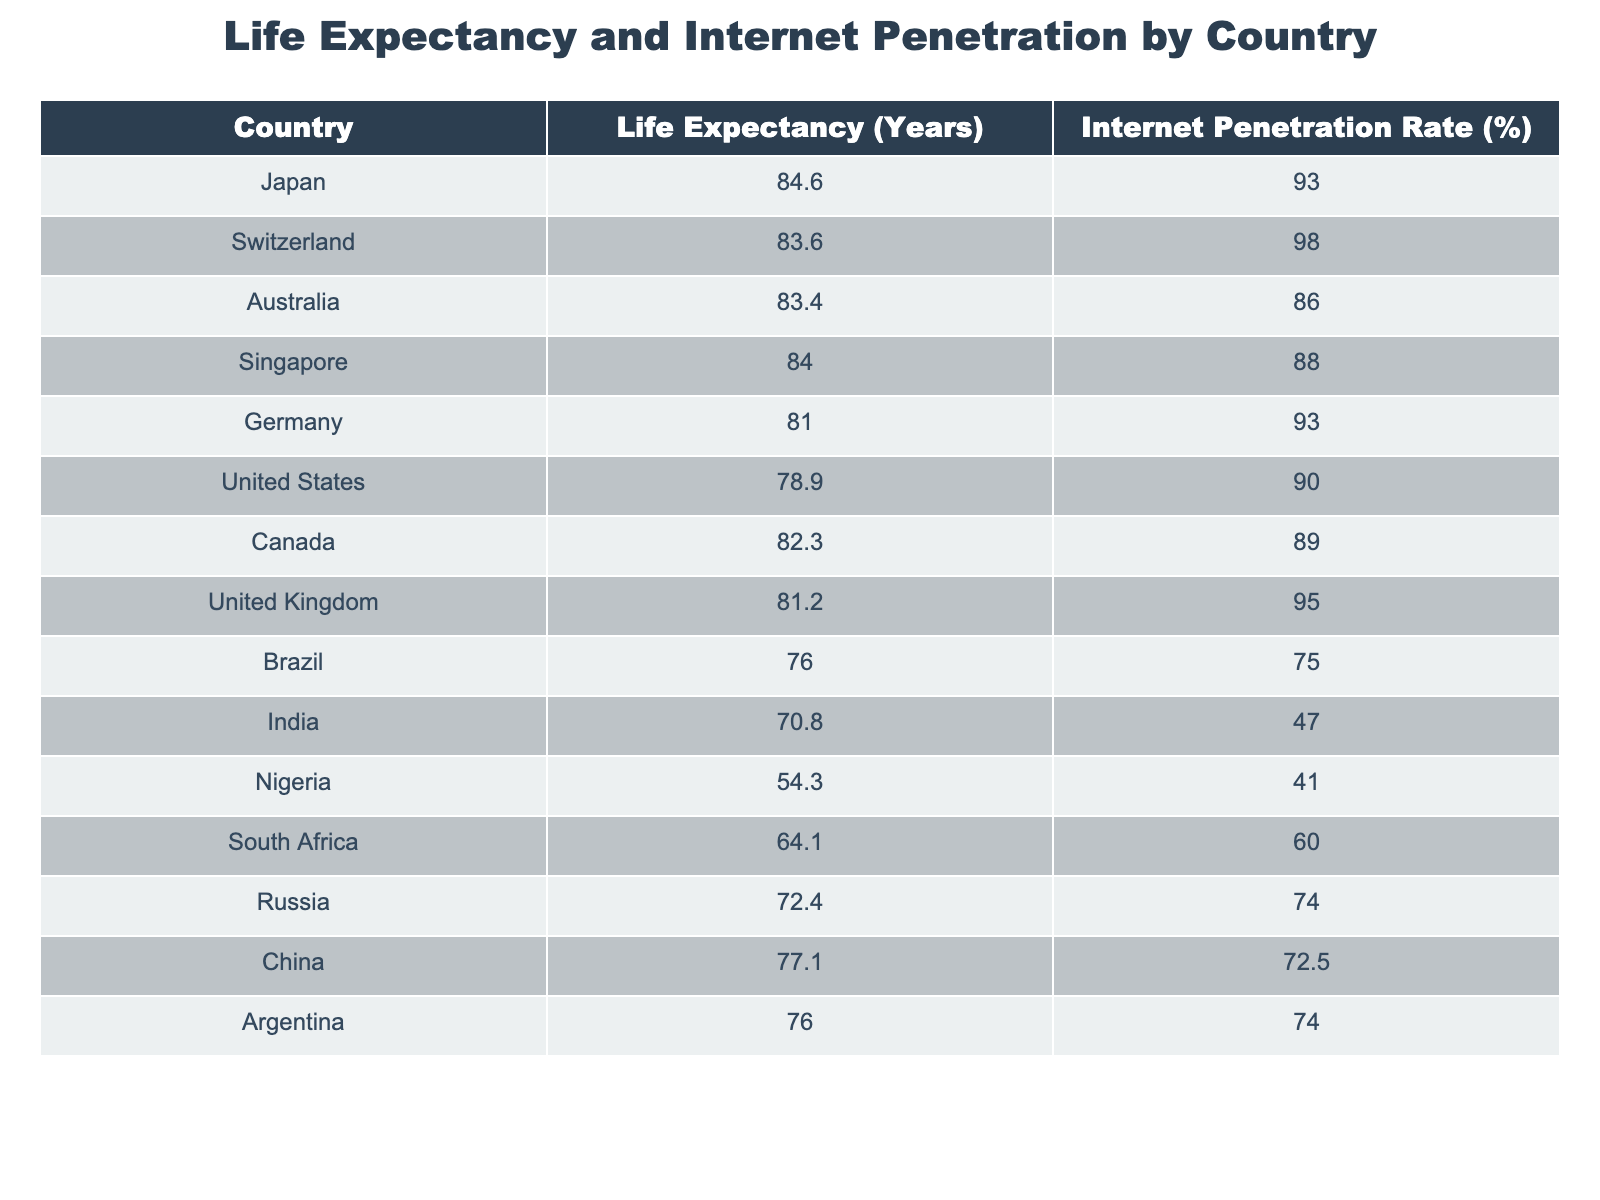What is the life expectancy of Japan? Japan’s life expectancy is listed directly in the table as 84.6 years.
Answer: 84.6 years What is the internet penetration rate in Brazil? The internet penetration rate for Brazil is provided in the table as 75.0%.
Answer: 75.0% Which country has the highest internet penetration rate? By comparing the internet penetration rates in the table, Switzerland has the highest rate at 98.0%.
Answer: Switzerland Is the life expectancy of Nigeria higher than that of India? Nigeria's life expectancy is 54.3 years, and India’s is 70.8 years. Since 54.3 is less than 70.8, the answer is no.
Answer: No What is the difference in life expectancy between Australia and the United States? The life expectancy in Australia is 83.4 years and in the United States is 78.9 years. The difference is calculated as 83.4 - 78.9 = 4.5 years.
Answer: 4.5 years What is the average life expectancy of the countries listed? To calculate the average, sum all life expectancies: 84.6 + 83.6 + 83.4 + 84.0 + 81.0 + 78.9 + 82.3 + 81.2 + 76.0 + 70.8 + 54.3 + 64.1 + 72.4 + 77.1 + 76.0 = 1220.8, then divide by the number of countries (15): 1220.8 / 15 = 81.39 years (approximately).
Answer: 81.39 years Are there any countries with both high life expectancy and high internet penetration? By examining the table, countries like Japan (84.6 years, 93.0%) and Switzerland (83.6 years, 98.0%) fall into this category, indicating there are indeed countries with high values in both metrics.
Answer: Yes What is the median internet penetration rate for the listed countries? First, list the internet penetration rates in numerical order: 41.0, 47.0, 60.0, 72.5, 74.0, 75.0, 86.0, 88.0, 89.0, 90.0, 93.0, 95.0, 98.0. Since there are 15 rates, the median is the 8th value, which is 88.0%.
Answer: 88.0% Which countries have a life expectancy above 80 years and an internet penetration rate above 85%? Checking the table, countries that meet these criteria are Japan (84.6 years, 93.0%), Switzerland (83.6 years, 98.0%), Australia (83.4 years, 86.0%), Singapore (84.0 years, 88.0%), Germany (81.0 years, 93.0%), and Canada (82.3 years, 89.0%).
Answer: Japan, Switzerland, Australia, Singapore, Germany, Canada 